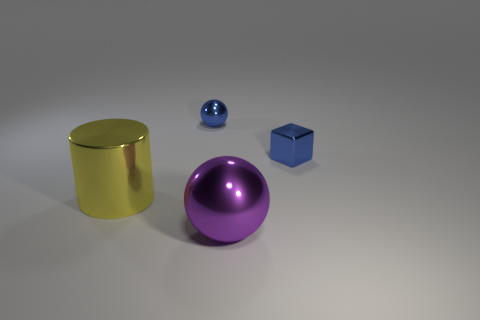What number of other objects are there of the same color as the small ball?
Offer a very short reply. 1. There is a ball that is to the left of the big shiny sphere; is its size the same as the sphere in front of the blue cube?
Offer a very short reply. No. There is a thing on the left side of the blue shiny object to the left of the large purple thing; how big is it?
Give a very brief answer. Large. The object that is behind the yellow shiny cylinder and to the left of the small blue metallic cube is made of what material?
Your response must be concise. Metal. The small shiny ball is what color?
Offer a very short reply. Blue. Are there any other things that have the same material as the big sphere?
Provide a short and direct response. Yes. There is a blue thing behind the small block; what shape is it?
Offer a terse response. Sphere. Are there any big purple objects in front of the blue object that is to the right of the tiny blue object that is on the left side of the blue block?
Offer a terse response. Yes. Is there anything else that has the same shape as the purple metallic thing?
Provide a short and direct response. Yes. Is there a tiny block?
Ensure brevity in your answer.  Yes. 